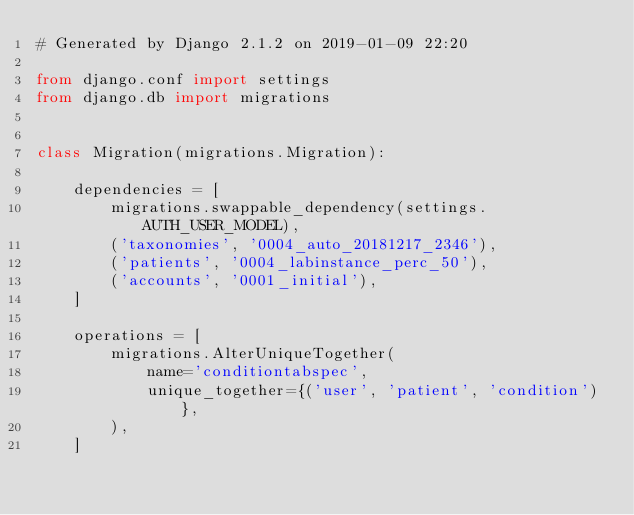<code> <loc_0><loc_0><loc_500><loc_500><_Python_># Generated by Django 2.1.2 on 2019-01-09 22:20

from django.conf import settings
from django.db import migrations


class Migration(migrations.Migration):

    dependencies = [
        migrations.swappable_dependency(settings.AUTH_USER_MODEL),
        ('taxonomies', '0004_auto_20181217_2346'),
        ('patients', '0004_labinstance_perc_50'),
        ('accounts', '0001_initial'),
    ]

    operations = [
        migrations.AlterUniqueTogether(
            name='conditiontabspec',
            unique_together={('user', 'patient', 'condition')},
        ),
    ]
</code> 